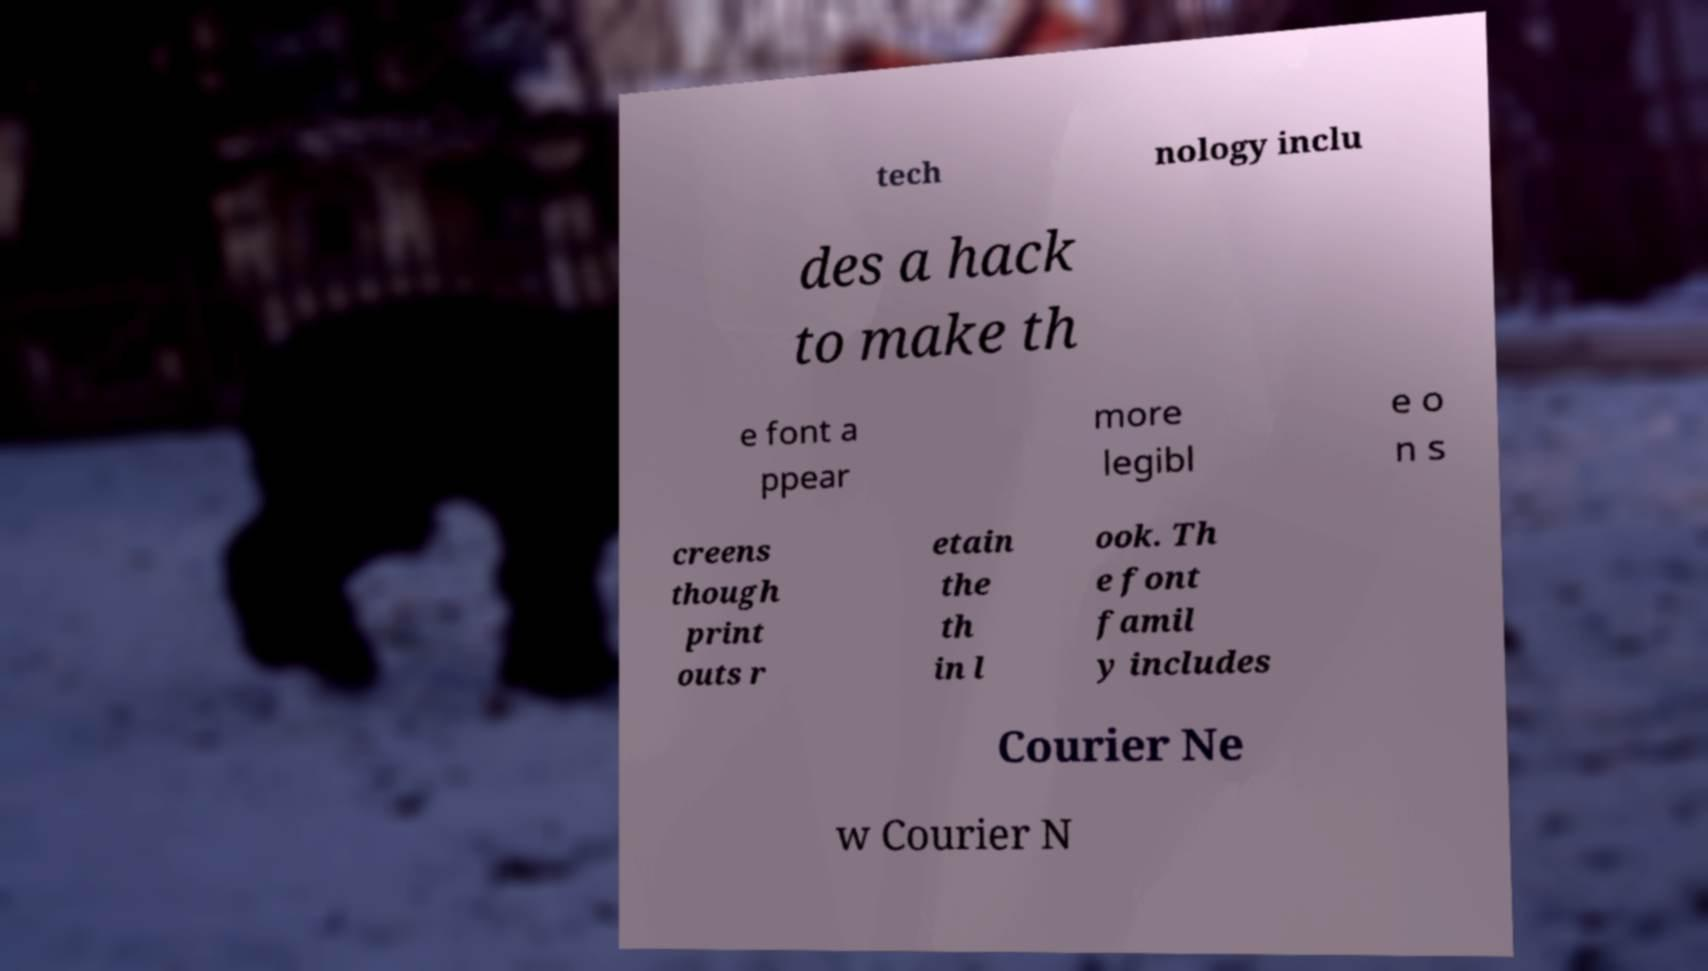Could you extract and type out the text from this image? tech nology inclu des a hack to make th e font a ppear more legibl e o n s creens though print outs r etain the th in l ook. Th e font famil y includes Courier Ne w Courier N 